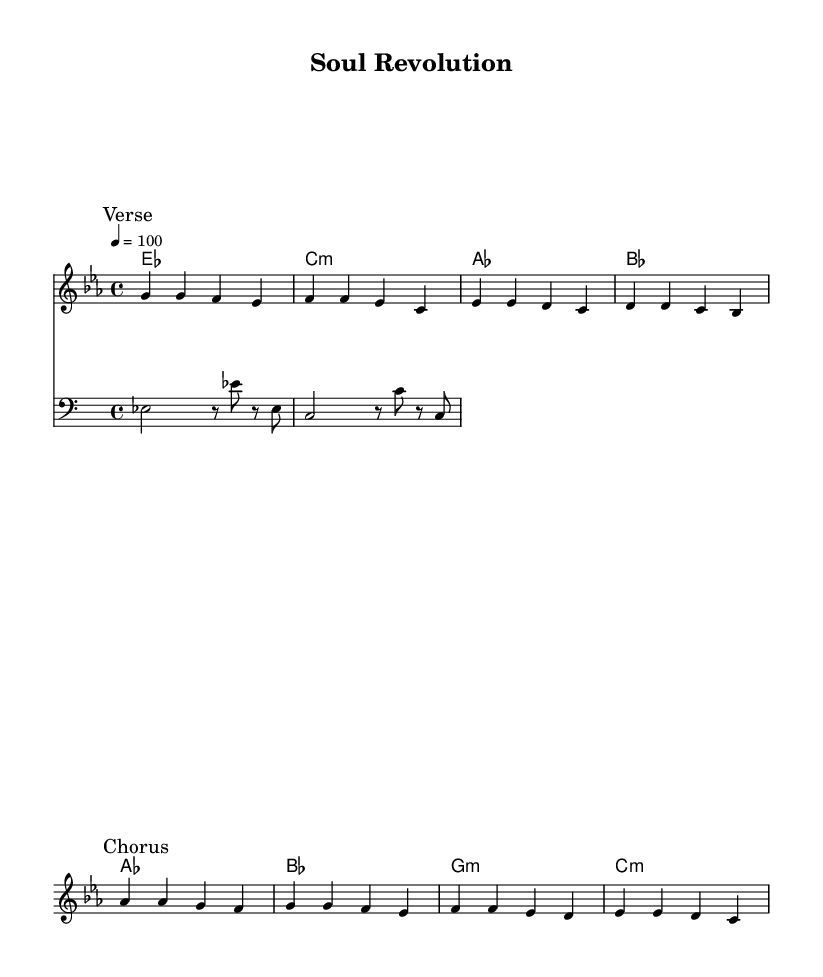What is the key signature of this music? The key signature indicated in the music is E flat major, which has three flats: B flat, E flat, and A flat. This is evident at the beginning of the score where the key signature is displayed.
Answer: E flat major What is the time signature of this music? The time signature shown in the music is 4/4, which means there are four beats in each measure and the quarter note gets one beat. This is typically represented at the start of the piece.
Answer: 4/4 What is the tempo marking for this piece? The tempo marking for this music is indicated as quarter note equals 100, meaning the piece should be played at a speed of 100 beats per minute, which can be found at the beginning of the notation.
Answer: 100 How many measures are in the verse section? The verse section consists of four measures as identified by the markings within the music that indicate the beginning and the structure of each part. Counting each segment between the breaks indicates four complete measures.
Answer: Four What type of musical performance technique is suggested in the lyrics? The lyrics suggest a theme of empowerment and resistance, highlighted by phrases such as 'Lift our voices, break the chains', indicating a call for social change and cultural pride. This technique is common in rhythm and blues, where lyrics convey strong emotional messages.
Answer: Empowerment What is the root chord of the first measure? The chord for the first measure is E flat major, which is clearly indicated in the chord names section above each measure. The symbols align with the harmonic structure of the melody.
Answer: E flat major What is the overall theme conveyed in the lyrics? The overall theme in the lyrics revolves around cultural pride and social change, focusing on historical acknowledgment and the quest for liberation, which reflects the essence of funk-infused R&B from the 1970s. This is expressed through the poetic lines that emphasize standing tall and a soul revolution.
Answer: Cultural pride and social change 